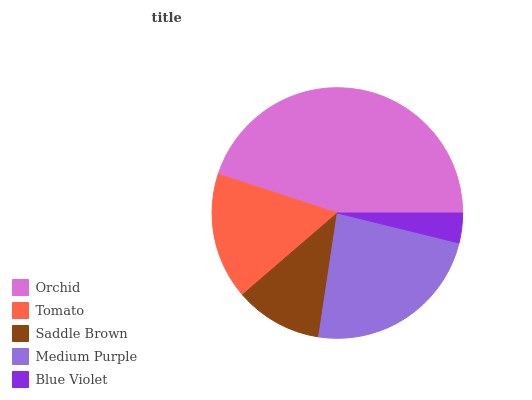Is Blue Violet the minimum?
Answer yes or no. Yes. Is Orchid the maximum?
Answer yes or no. Yes. Is Tomato the minimum?
Answer yes or no. No. Is Tomato the maximum?
Answer yes or no. No. Is Orchid greater than Tomato?
Answer yes or no. Yes. Is Tomato less than Orchid?
Answer yes or no. Yes. Is Tomato greater than Orchid?
Answer yes or no. No. Is Orchid less than Tomato?
Answer yes or no. No. Is Tomato the high median?
Answer yes or no. Yes. Is Tomato the low median?
Answer yes or no. Yes. Is Medium Purple the high median?
Answer yes or no. No. Is Saddle Brown the low median?
Answer yes or no. No. 